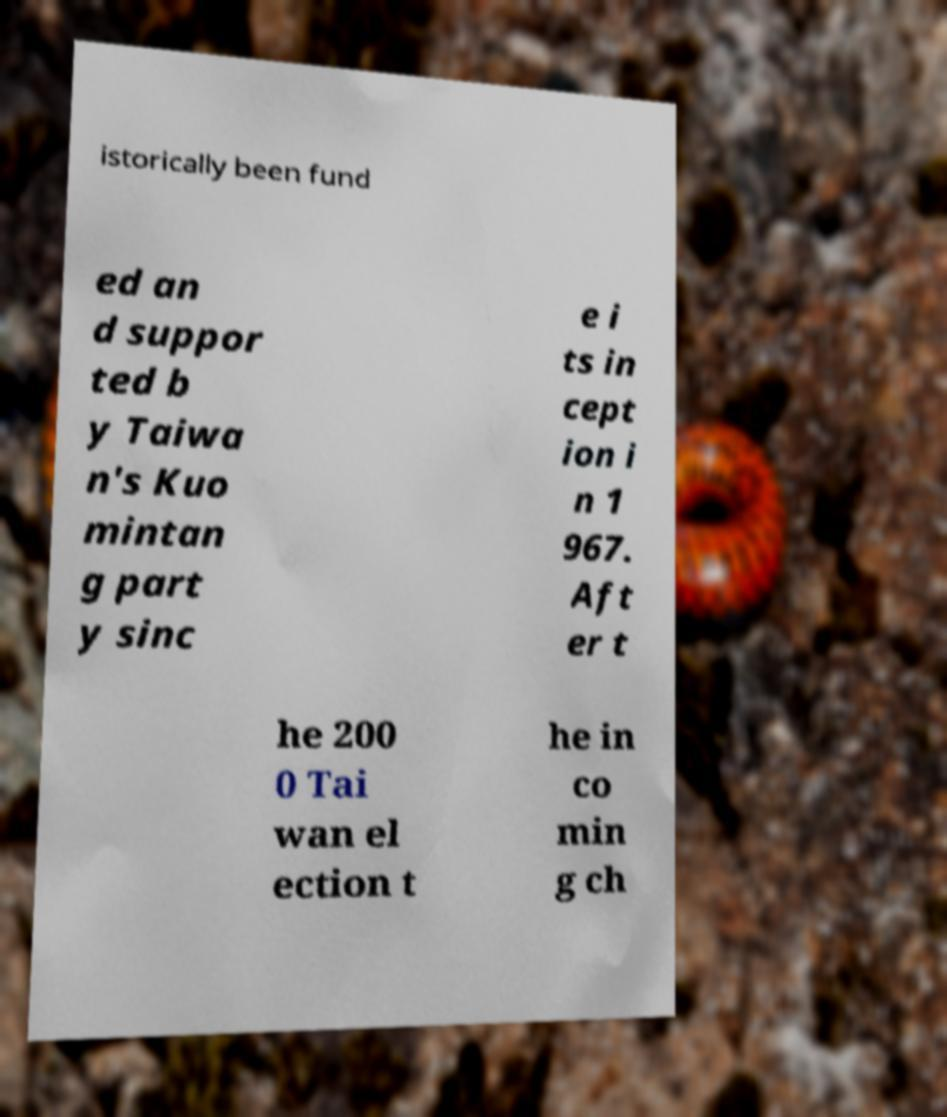What messages or text are displayed in this image? I need them in a readable, typed format. istorically been fund ed an d suppor ted b y Taiwa n's Kuo mintan g part y sinc e i ts in cept ion i n 1 967. Aft er t he 200 0 Tai wan el ection t he in co min g ch 